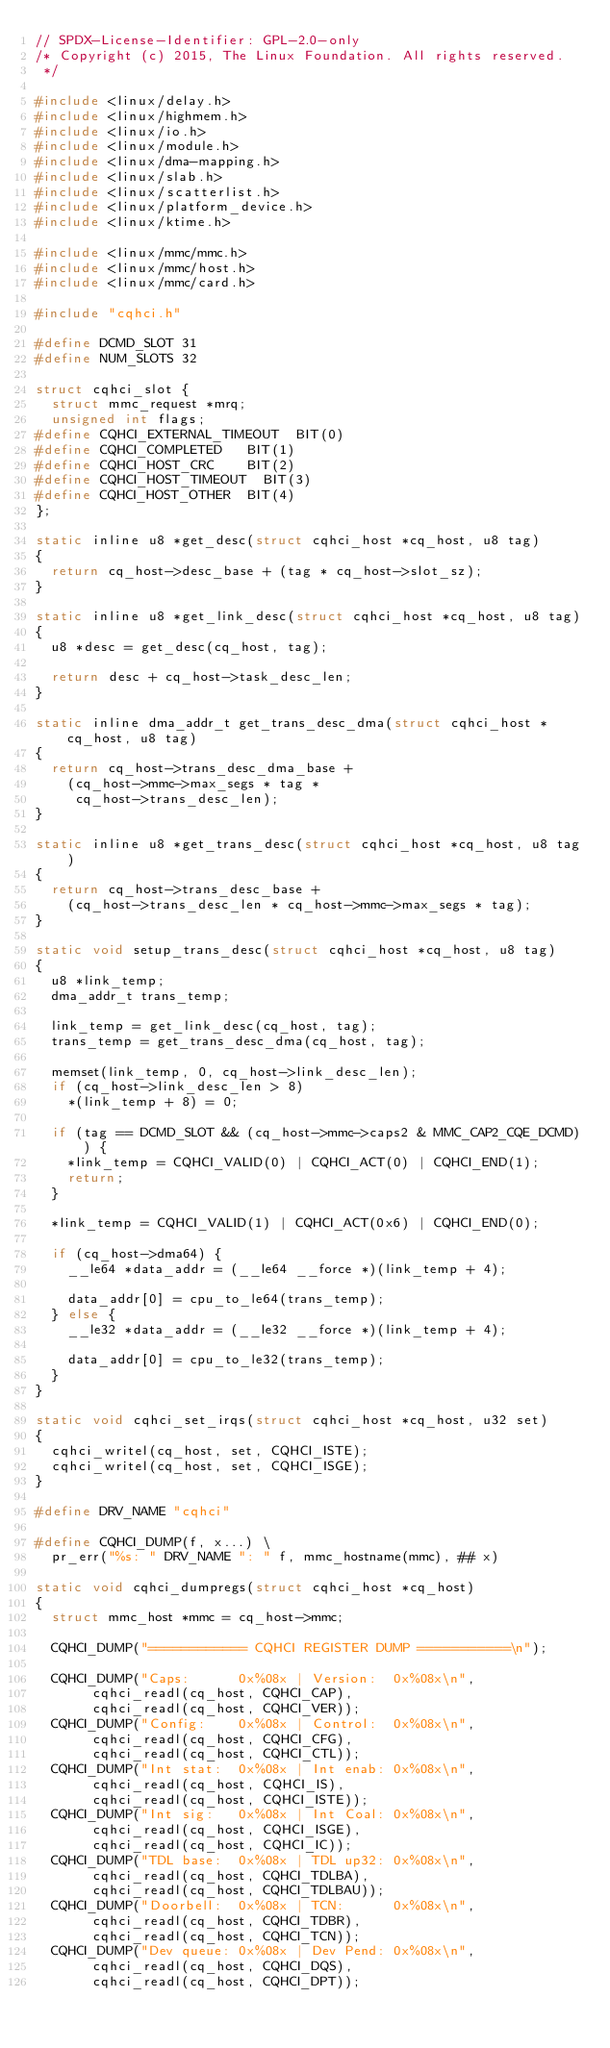<code> <loc_0><loc_0><loc_500><loc_500><_C_>// SPDX-License-Identifier: GPL-2.0-only
/* Copyright (c) 2015, The Linux Foundation. All rights reserved.
 */

#include <linux/delay.h>
#include <linux/highmem.h>
#include <linux/io.h>
#include <linux/module.h>
#include <linux/dma-mapping.h>
#include <linux/slab.h>
#include <linux/scatterlist.h>
#include <linux/platform_device.h>
#include <linux/ktime.h>

#include <linux/mmc/mmc.h>
#include <linux/mmc/host.h>
#include <linux/mmc/card.h>

#include "cqhci.h"

#define DCMD_SLOT 31
#define NUM_SLOTS 32

struct cqhci_slot {
	struct mmc_request *mrq;
	unsigned int flags;
#define CQHCI_EXTERNAL_TIMEOUT	BIT(0)
#define CQHCI_COMPLETED		BIT(1)
#define CQHCI_HOST_CRC		BIT(2)
#define CQHCI_HOST_TIMEOUT	BIT(3)
#define CQHCI_HOST_OTHER	BIT(4)
};

static inline u8 *get_desc(struct cqhci_host *cq_host, u8 tag)
{
	return cq_host->desc_base + (tag * cq_host->slot_sz);
}

static inline u8 *get_link_desc(struct cqhci_host *cq_host, u8 tag)
{
	u8 *desc = get_desc(cq_host, tag);

	return desc + cq_host->task_desc_len;
}

static inline dma_addr_t get_trans_desc_dma(struct cqhci_host *cq_host, u8 tag)
{
	return cq_host->trans_desc_dma_base +
		(cq_host->mmc->max_segs * tag *
		 cq_host->trans_desc_len);
}

static inline u8 *get_trans_desc(struct cqhci_host *cq_host, u8 tag)
{
	return cq_host->trans_desc_base +
		(cq_host->trans_desc_len * cq_host->mmc->max_segs * tag);
}

static void setup_trans_desc(struct cqhci_host *cq_host, u8 tag)
{
	u8 *link_temp;
	dma_addr_t trans_temp;

	link_temp = get_link_desc(cq_host, tag);
	trans_temp = get_trans_desc_dma(cq_host, tag);

	memset(link_temp, 0, cq_host->link_desc_len);
	if (cq_host->link_desc_len > 8)
		*(link_temp + 8) = 0;

	if (tag == DCMD_SLOT && (cq_host->mmc->caps2 & MMC_CAP2_CQE_DCMD)) {
		*link_temp = CQHCI_VALID(0) | CQHCI_ACT(0) | CQHCI_END(1);
		return;
	}

	*link_temp = CQHCI_VALID(1) | CQHCI_ACT(0x6) | CQHCI_END(0);

	if (cq_host->dma64) {
		__le64 *data_addr = (__le64 __force *)(link_temp + 4);

		data_addr[0] = cpu_to_le64(trans_temp);
	} else {
		__le32 *data_addr = (__le32 __force *)(link_temp + 4);

		data_addr[0] = cpu_to_le32(trans_temp);
	}
}

static void cqhci_set_irqs(struct cqhci_host *cq_host, u32 set)
{
	cqhci_writel(cq_host, set, CQHCI_ISTE);
	cqhci_writel(cq_host, set, CQHCI_ISGE);
}

#define DRV_NAME "cqhci"

#define CQHCI_DUMP(f, x...) \
	pr_err("%s: " DRV_NAME ": " f, mmc_hostname(mmc), ## x)

static void cqhci_dumpregs(struct cqhci_host *cq_host)
{
	struct mmc_host *mmc = cq_host->mmc;

	CQHCI_DUMP("============ CQHCI REGISTER DUMP ===========\n");

	CQHCI_DUMP("Caps:      0x%08x | Version:  0x%08x\n",
		   cqhci_readl(cq_host, CQHCI_CAP),
		   cqhci_readl(cq_host, CQHCI_VER));
	CQHCI_DUMP("Config:    0x%08x | Control:  0x%08x\n",
		   cqhci_readl(cq_host, CQHCI_CFG),
		   cqhci_readl(cq_host, CQHCI_CTL));
	CQHCI_DUMP("Int stat:  0x%08x | Int enab: 0x%08x\n",
		   cqhci_readl(cq_host, CQHCI_IS),
		   cqhci_readl(cq_host, CQHCI_ISTE));
	CQHCI_DUMP("Int sig:   0x%08x | Int Coal: 0x%08x\n",
		   cqhci_readl(cq_host, CQHCI_ISGE),
		   cqhci_readl(cq_host, CQHCI_IC));
	CQHCI_DUMP("TDL base:  0x%08x | TDL up32: 0x%08x\n",
		   cqhci_readl(cq_host, CQHCI_TDLBA),
		   cqhci_readl(cq_host, CQHCI_TDLBAU));
	CQHCI_DUMP("Doorbell:  0x%08x | TCN:      0x%08x\n",
		   cqhci_readl(cq_host, CQHCI_TDBR),
		   cqhci_readl(cq_host, CQHCI_TCN));
	CQHCI_DUMP("Dev queue: 0x%08x | Dev Pend: 0x%08x\n",
		   cqhci_readl(cq_host, CQHCI_DQS),
		   cqhci_readl(cq_host, CQHCI_DPT));</code> 